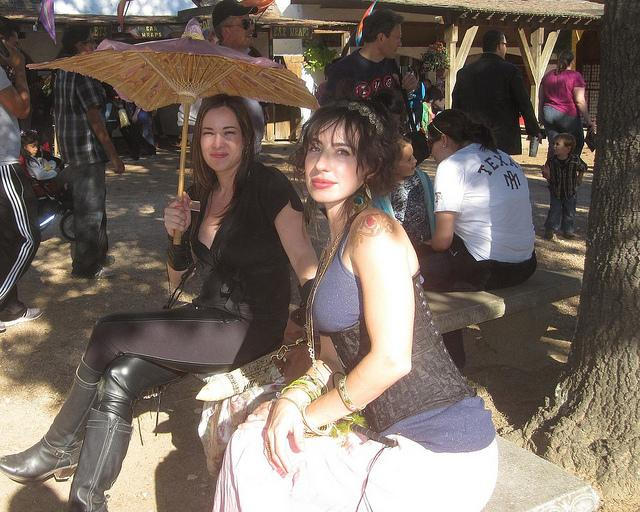The umbrella is made of what material?

Choices:
A) plastic
B) bamboo
C) denim
D) polyester bamboo 